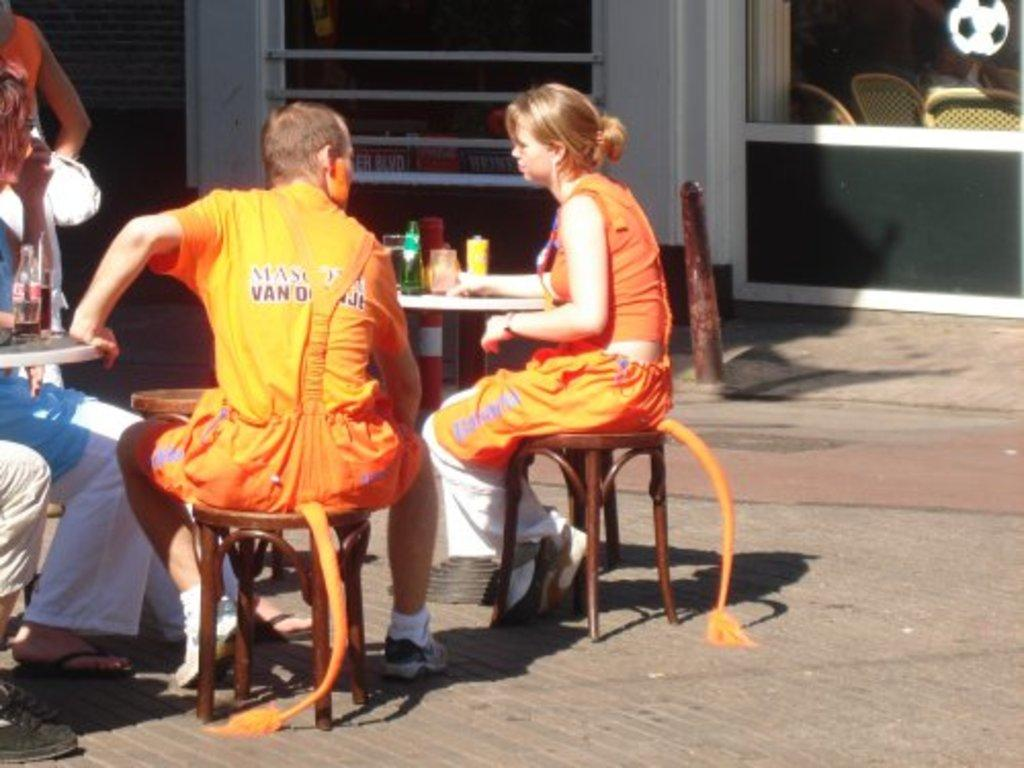How many people are seated in the image? There are two people seated on chairs in the image. What objects are on the table in the image? There are bottles and glasses on the table in the image. What is the woman in the image doing? The woman is standing in the image. What type of toothpaste is being used by the people in the image? There is no toothpaste present in the image. What is the size of the chairs the people are seated on? The provided facts do not mention the size of the chairs, so it cannot be determined from the image. 